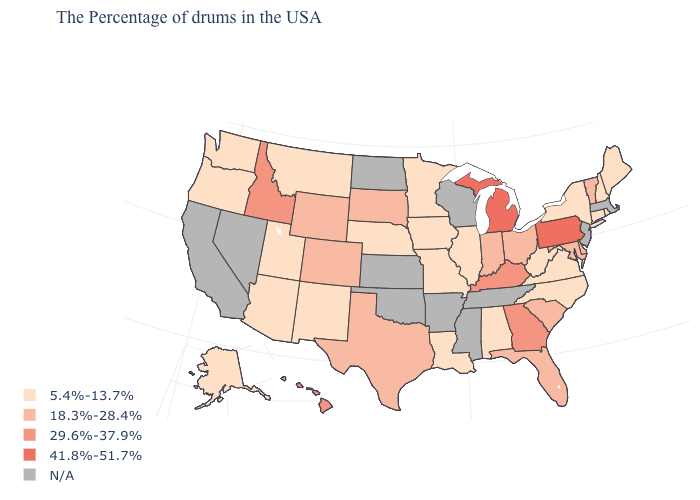Is the legend a continuous bar?
Answer briefly. No. Name the states that have a value in the range 18.3%-28.4%?
Quick response, please. Vermont, Delaware, Maryland, South Carolina, Ohio, Florida, Indiana, Texas, South Dakota, Wyoming, Colorado. Name the states that have a value in the range 5.4%-13.7%?
Quick response, please. Maine, Rhode Island, New Hampshire, Connecticut, New York, Virginia, North Carolina, West Virginia, Alabama, Illinois, Louisiana, Missouri, Minnesota, Iowa, Nebraska, New Mexico, Utah, Montana, Arizona, Washington, Oregon, Alaska. What is the value of Virginia?
Answer briefly. 5.4%-13.7%. What is the lowest value in the West?
Keep it brief. 5.4%-13.7%. Which states hav the highest value in the MidWest?
Be succinct. Michigan. What is the value of Hawaii?
Keep it brief. 29.6%-37.9%. Does the first symbol in the legend represent the smallest category?
Quick response, please. Yes. What is the lowest value in the West?
Answer briefly. 5.4%-13.7%. Is the legend a continuous bar?
Answer briefly. No. What is the highest value in the South ?
Be succinct. 29.6%-37.9%. What is the lowest value in the USA?
Short answer required. 5.4%-13.7%. Name the states that have a value in the range 41.8%-51.7%?
Be succinct. Pennsylvania, Michigan. Does New York have the highest value in the USA?
Quick response, please. No. 